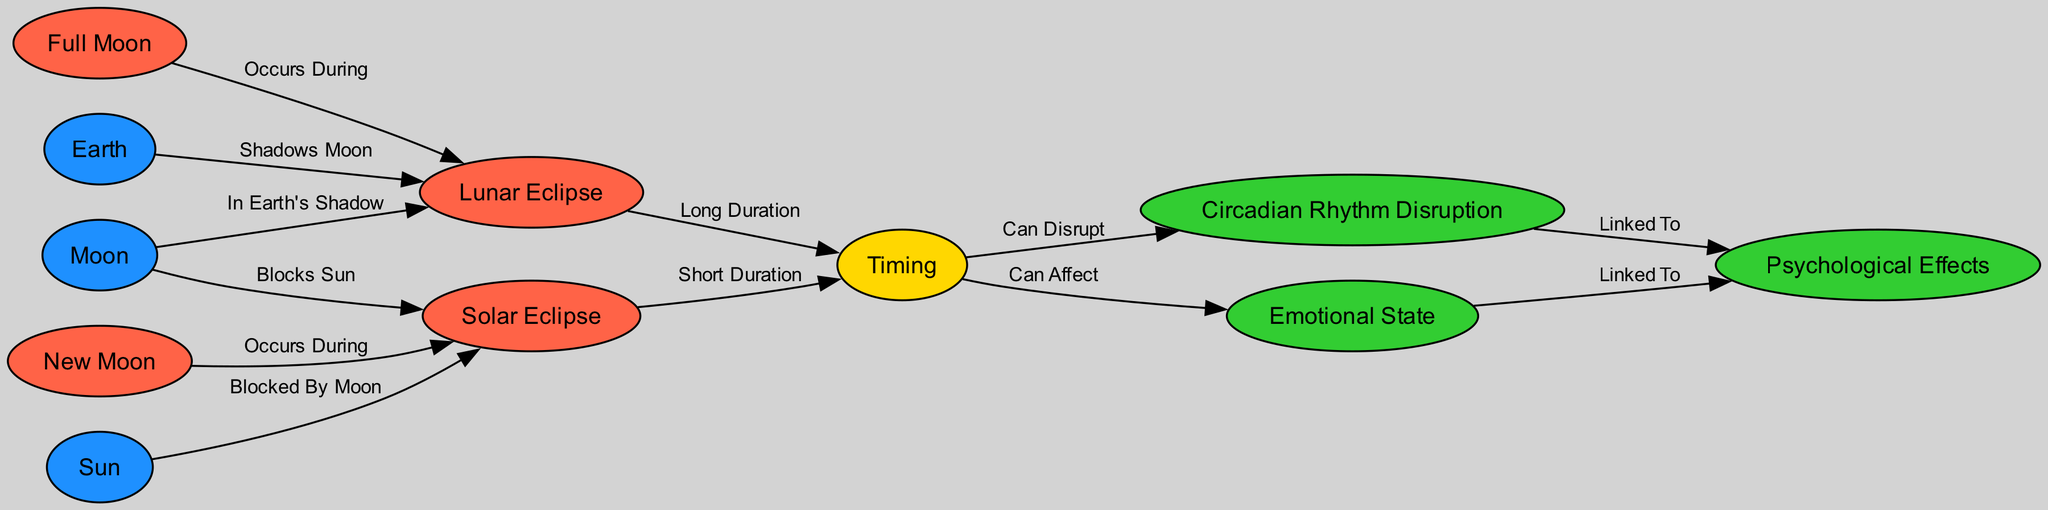What occurs during a new moon? A new moon is when the solar eclipse occurs. In the diagram, the connection from the "new moon" node to the "solar eclipse" node is labeled "Occurs During," indicating this relationship.
Answer: Solar Eclipse How long does a lunar eclipse last compared to a solar eclipse? The diagram shows a direct relationship indicating that a lunar eclipse has a "Long Duration" while a solar eclipse has a "Short Duration." By comparing these two nodes connected to the "timing" node, we can easily deduce the duration difference.
Answer: Long Duration What does the moon do during a solar eclipse? The diagram states that the moon "Blocks Sun" during a solar eclipse, as indicated by the edge connecting the "moon" and "solar eclipse" nodes with that label.
Answer: Blocks Sun Which celestial body casts a shadow on the moon during a lunar eclipse? According to the diagram, during a lunar eclipse, it is the "earth" that "Shadows Moon," as indicated by the edge from "earth" to "lunar eclipse."
Answer: Earth What psychological effect can be linked to disruptions in circadian rhythm? The diagram connects "circadian rhythm" to "psychological effects" with the label "Linked To." This linkage shows that changes in circadian rhythm may have psychological consequences.
Answer: Psychological Effects What type of eclipse occurs during a full moon? The diagram explicitly states that a lunar eclipse occurs during a full moon through the edge labeled "Occurs During." This clearly outlines the type of eclipse happening at that time.
Answer: Lunar Eclipse How many nodes related to psychological effects are in this diagram? There are three nodes related to psychological effects in the diagram: "psychological effects," "circadian rhythm," and "emotional state." Counting these nodes provides the answer.
Answer: Three Can timing affect emotional state? Yes, according to the diagram, timing "Can Affect" emotional state, as indicated by the edge connecting "timing" to "emotional state." This relationship implies that the timing of events may influence how one feels.
Answer: Yes What type of diagram is this? The diagram represents relationships concerning lunar and solar eclipses as well as their timing and psychological impacts, which categorizes it as an Astronomy Diagram, specifically focused on eclipse timing effects.
Answer: Astronomy Diagram 